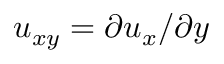<formula> <loc_0><loc_0><loc_500><loc_500>u _ { x y } = \partial u _ { x } / \partial y</formula> 